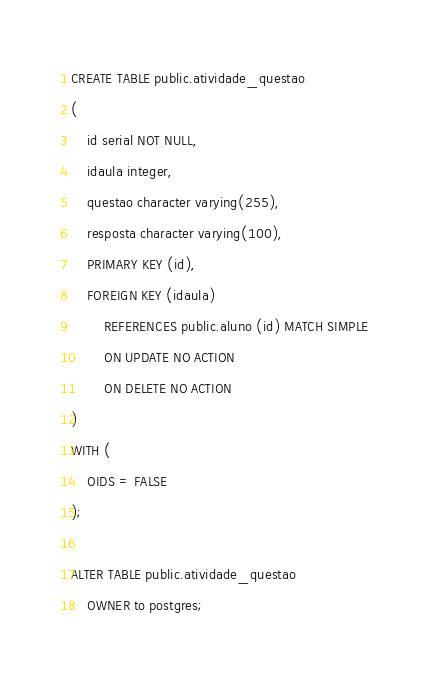Convert code to text. <code><loc_0><loc_0><loc_500><loc_500><_SQL_>CREATE TABLE public.atividade_questao
(
    id serial NOT NULL,
    idaula integer,
    questao character varying(255),
    resposta character varying(100),
    PRIMARY KEY (id),
    FOREIGN KEY (idaula)
        REFERENCES public.aluno (id) MATCH SIMPLE
        ON UPDATE NO ACTION
        ON DELETE NO ACTION
)
WITH (
    OIDS = FALSE
);

ALTER TABLE public.atividade_questao
    OWNER to postgres;</code> 